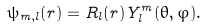Convert formula to latex. <formula><loc_0><loc_0><loc_500><loc_500>\psi _ { m , l } ( { r } ) = R _ { l } ( r ) Y _ { l } ^ { m } ( \theta , \varphi ) .</formula> 